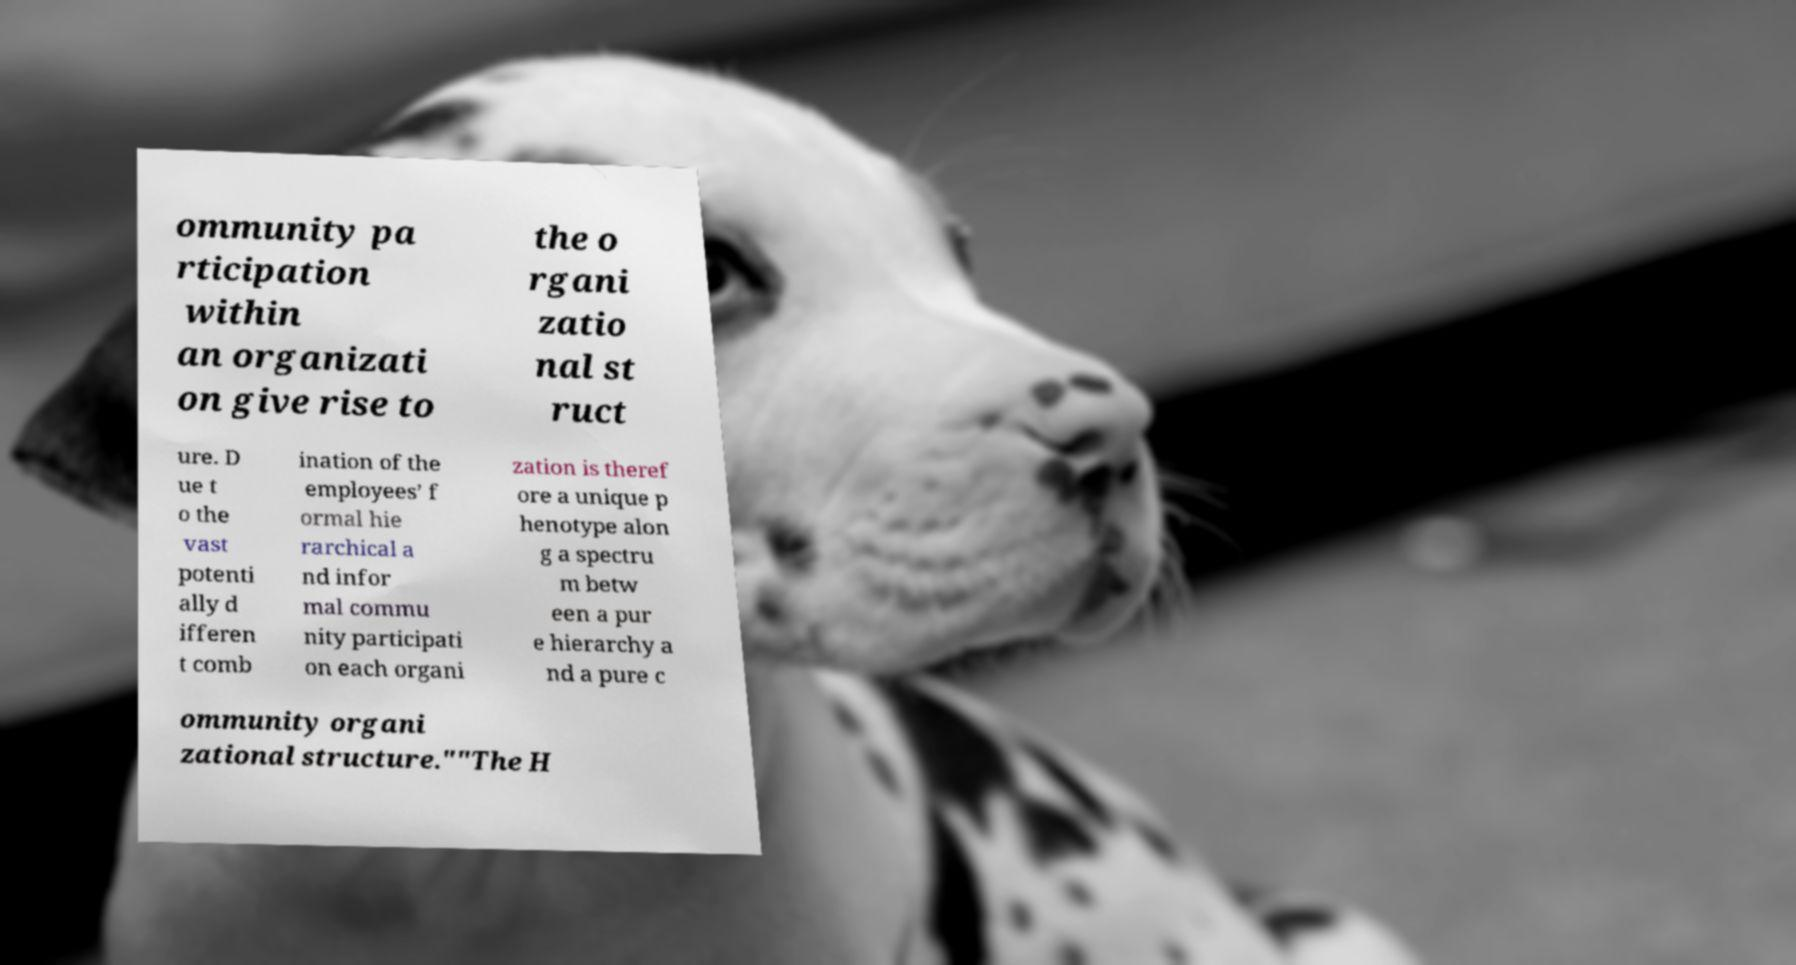Please identify and transcribe the text found in this image. ommunity pa rticipation within an organizati on give rise to the o rgani zatio nal st ruct ure. D ue t o the vast potenti ally d ifferen t comb ination of the employees’ f ormal hie rarchical a nd infor mal commu nity participati on each organi zation is theref ore a unique p henotype alon g a spectru m betw een a pur e hierarchy a nd a pure c ommunity organi zational structure.""The H 